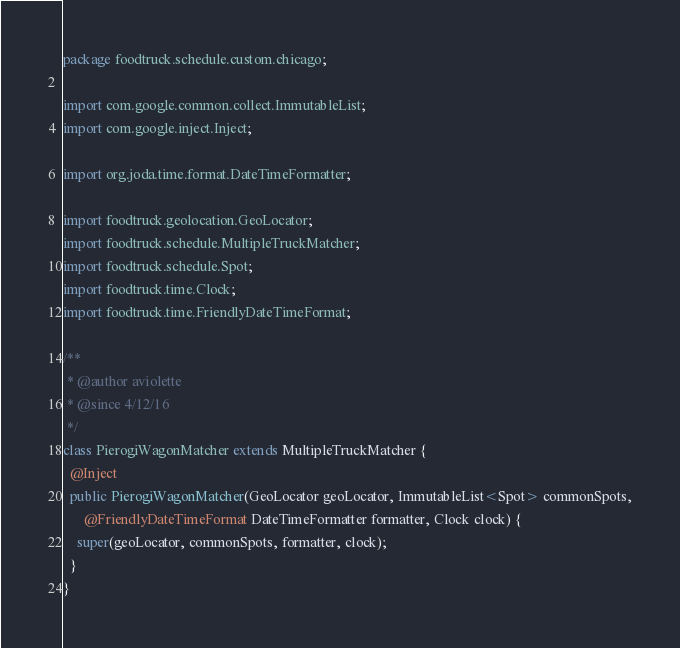<code> <loc_0><loc_0><loc_500><loc_500><_Java_>package foodtruck.schedule.custom.chicago;

import com.google.common.collect.ImmutableList;
import com.google.inject.Inject;

import org.joda.time.format.DateTimeFormatter;

import foodtruck.geolocation.GeoLocator;
import foodtruck.schedule.MultipleTruckMatcher;
import foodtruck.schedule.Spot;
import foodtruck.time.Clock;
import foodtruck.time.FriendlyDateTimeFormat;

/**
 * @author aviolette
 * @since 4/12/16
 */
class PierogiWagonMatcher extends MultipleTruckMatcher {
  @Inject
  public PierogiWagonMatcher(GeoLocator geoLocator, ImmutableList<Spot> commonSpots,
      @FriendlyDateTimeFormat DateTimeFormatter formatter, Clock clock) {
    super(geoLocator, commonSpots, formatter, clock);
  }
}
</code> 